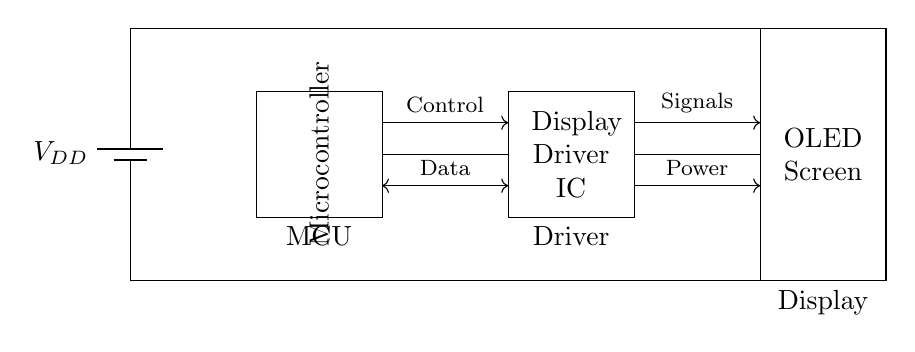What is the voltage source used in this circuit? The circuit diagram indicates a battery labeled V sub DD, which is the voltage source supplying power to the circuit components. Since it is identified as a battery, it functions as the main voltage source for the entire circuit.
Answer: V sub DD What component interfaces directly with the OLED screen? The connection from the display driver IC to the OLED screen shows that the display driver is responsible for providing power and signals to control the OLED screen's operation. This role indicates that the display driver IC is the component interfacing directly with theOLED screen.
Answer: Display Driver IC What kind of controller is shown in the circuit? The rectangle labeled "Microcontroller" indicates that the MCU (Microcontroller Unit) is responsible for managing the display driver and sending necessary data and control signals to it. This shows the specific type of controller used in this circuit.
Answer: Microcontroller How many main components are present in the circuit? The circuit contains three main components: the power supply (battery), the microcontroller, and the display driver IC. Each of these is essential for the overall function of the circuit, making the total count straightforward.
Answer: Three What type of signals are sent from the MCU to the display driver? The line labeled 'Data' indicates that the microcontroller transmits data signals to the display driver IC. Additionally, the line marked 'Control' shows that control signals are also sent from the microcontroller to the driver, indicating the type of information exchanged.
Answer: Data and Control What is the role of the display driver IC in this circuit? The display driver IC receives control and data signals from the microcontroller and converts these into the appropriate signals necessary to drive the OLED screen. This illustrates its crucial role in facilitating communication between the MCU and the display.
Answer: To control the OLED screen What direction do the power lines lead in the circuit? The diagram shows arrows indicating that power flows from the display driver IC to the OLED screen, suggesting that the driver provides the necessary power to operate the OLED screen. This directional information helps clarify the power delivery in the circuit.
Answer: To the OLED screen 